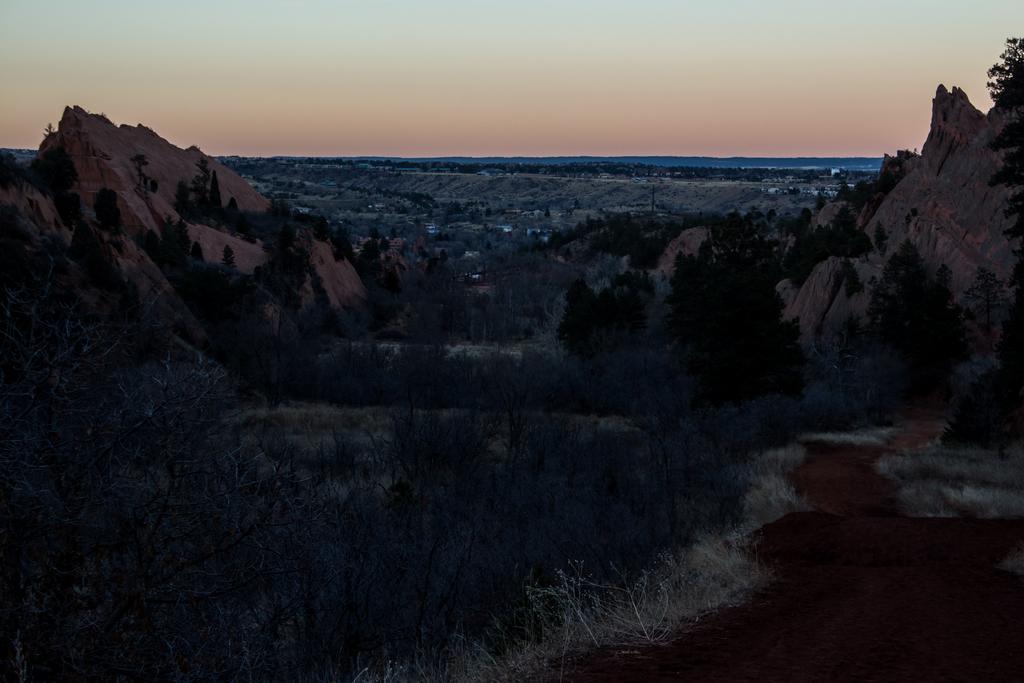Please provide a concise description of this image. In this picture we can observe some trees. There are two small hills on either sides of this picture. In the background there is a sky which is in orange color. 